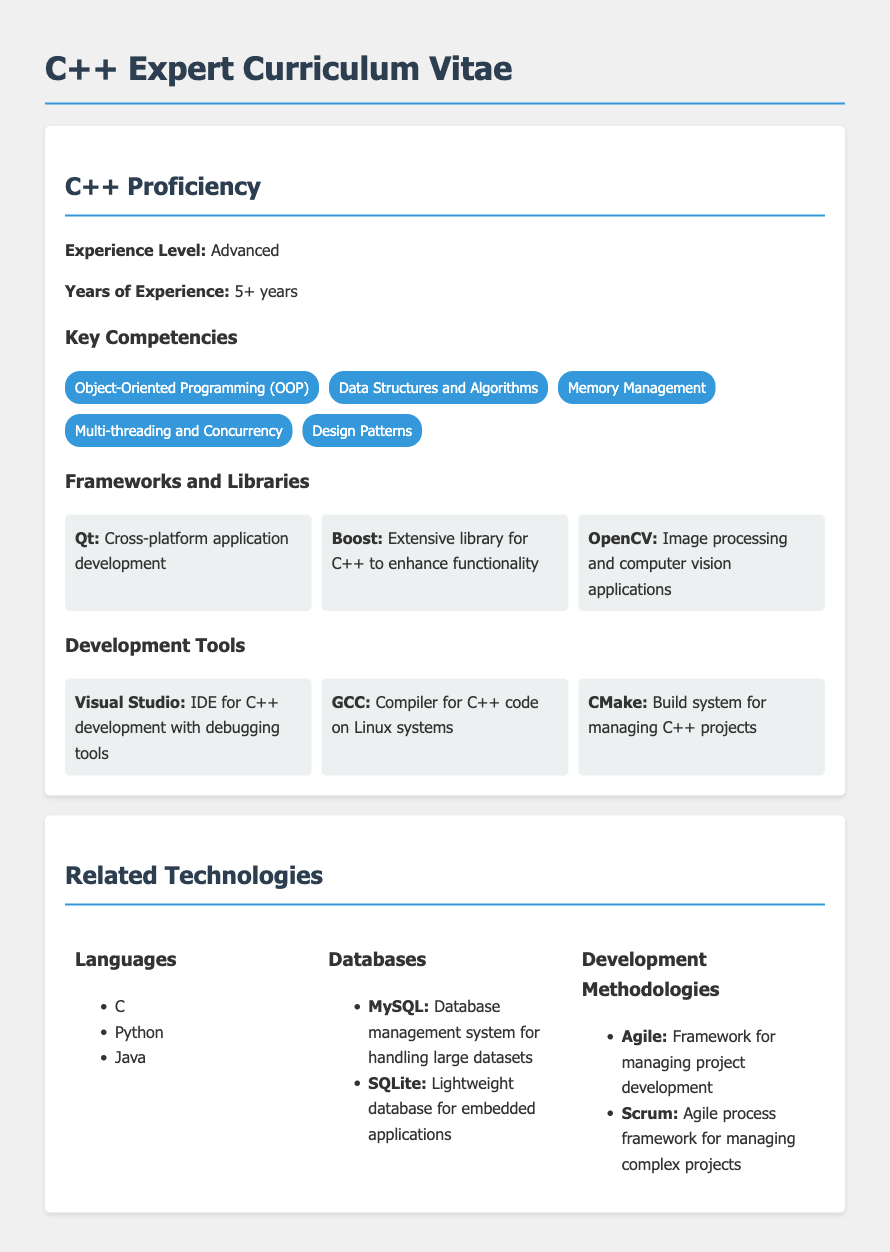what is the experience level in C++? The experience level in C++ is stated as Advanced in the document.
Answer: Advanced how many years of C++ experience does the candidate have? The document specifies that the candidate has over 5 years of experience in C++.
Answer: 5+ years name three key competencies listed for C++ proficiency. The document lists Object-Oriented Programming, Data Structures and Algorithms, and Memory Management as key competencies.
Answer: Object-Oriented Programming, Data Structures and Algorithms, Memory Management what framework is used for cross-platform application development? The document mentions Qt as the framework for cross-platform application development.
Answer: Qt which IDE is highlighted for C++ development in the tools section? The document highlights Visual Studio as the IDE for C++ development.
Answer: Visual Studio name one database management system mentioned in the related technologies section. The document mentions MySQL as a database management system.
Answer: MySQL what programming language is listed alongside C in the document? The document lists Python as a programming language alongside C.
Answer: Python which development methodology is described as a framework for managing project development? The document states Agile as a framework for managing project development.
Answer: Agile how many frameworks and libraries are mentioned in the C++ proficiency section? The document lists three frameworks and libraries under C++ proficiency.
Answer: 3 